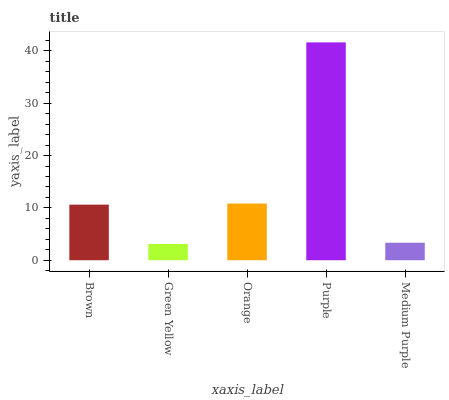Is Green Yellow the minimum?
Answer yes or no. Yes. Is Purple the maximum?
Answer yes or no. Yes. Is Orange the minimum?
Answer yes or no. No. Is Orange the maximum?
Answer yes or no. No. Is Orange greater than Green Yellow?
Answer yes or no. Yes. Is Green Yellow less than Orange?
Answer yes or no. Yes. Is Green Yellow greater than Orange?
Answer yes or no. No. Is Orange less than Green Yellow?
Answer yes or no. No. Is Brown the high median?
Answer yes or no. Yes. Is Brown the low median?
Answer yes or no. Yes. Is Purple the high median?
Answer yes or no. No. Is Orange the low median?
Answer yes or no. No. 